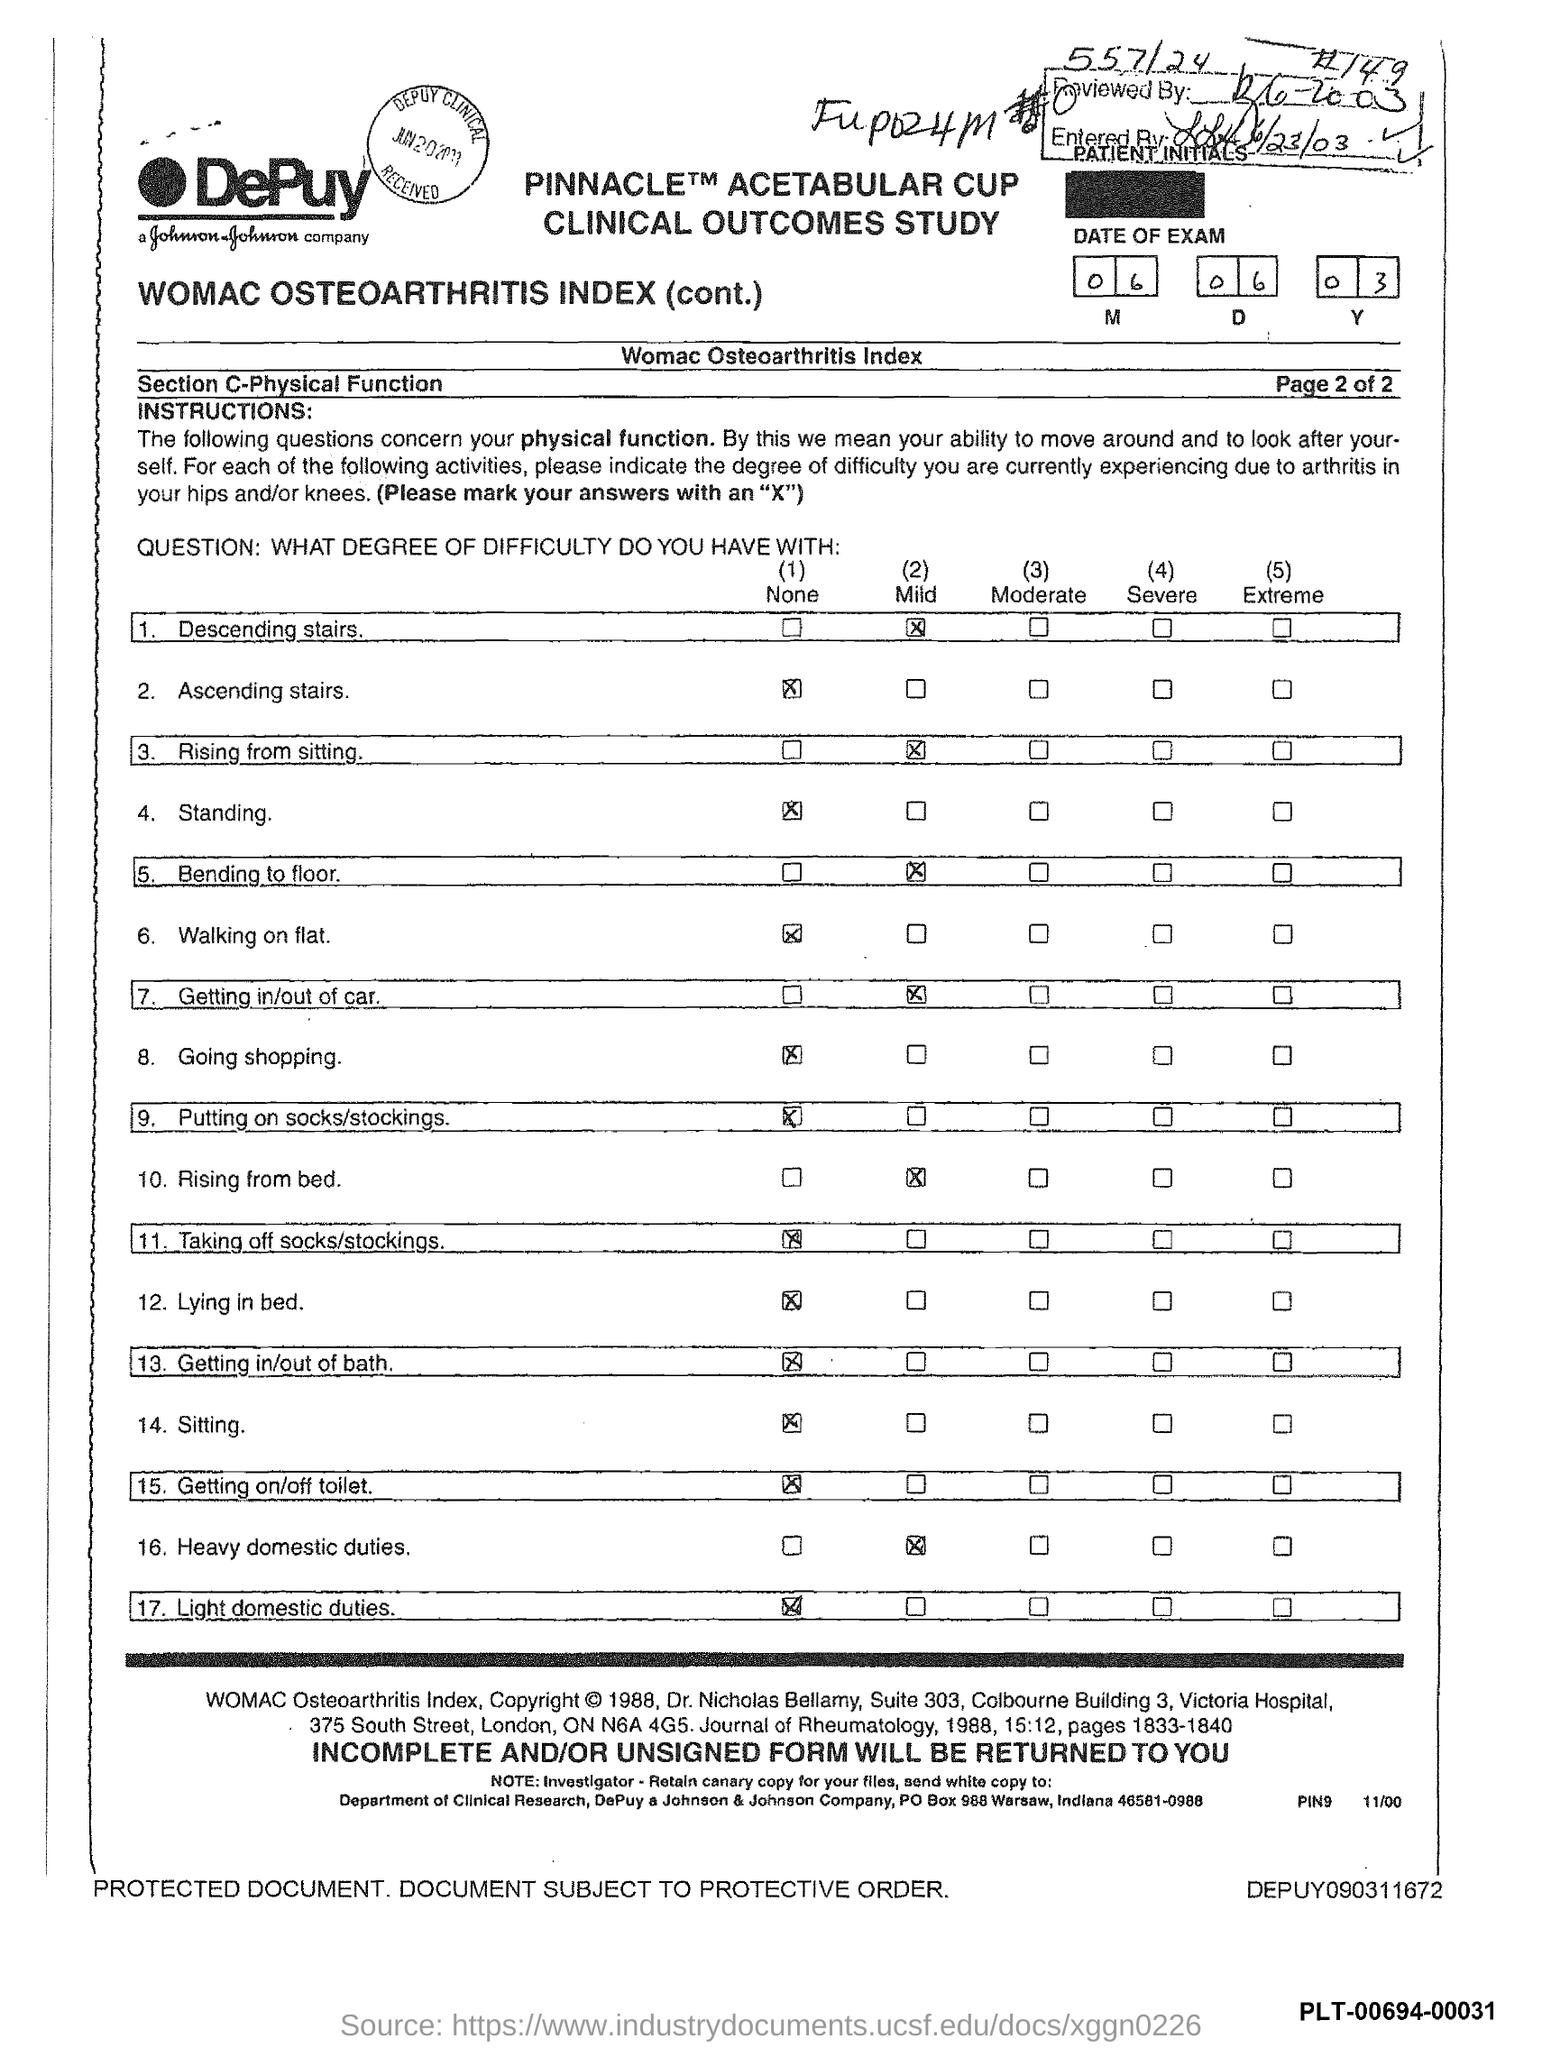What is the po box no. of johnson & johnson company ?
Provide a short and direct response. 988. In which state is johnson & johnson company located ?
Make the answer very short. Indiana. 